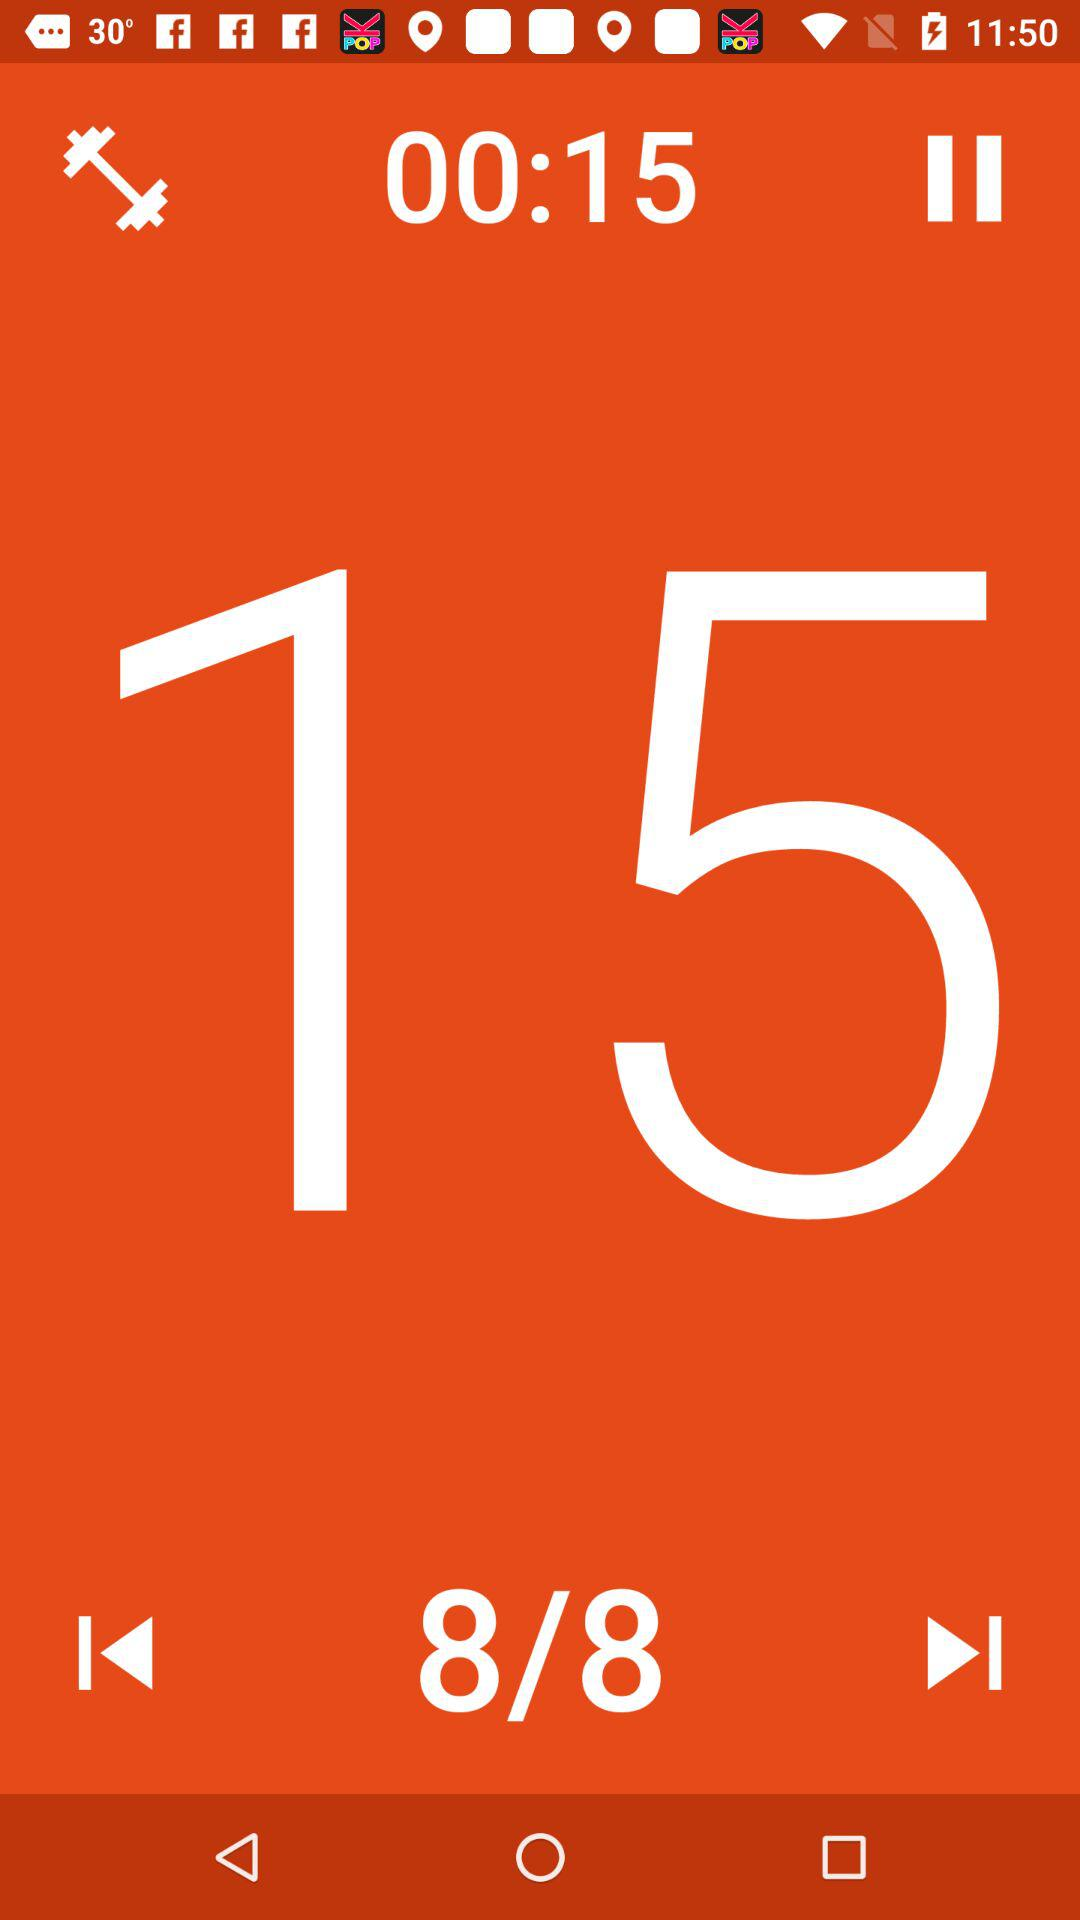What is the number of slides? The number of slides is 8. 